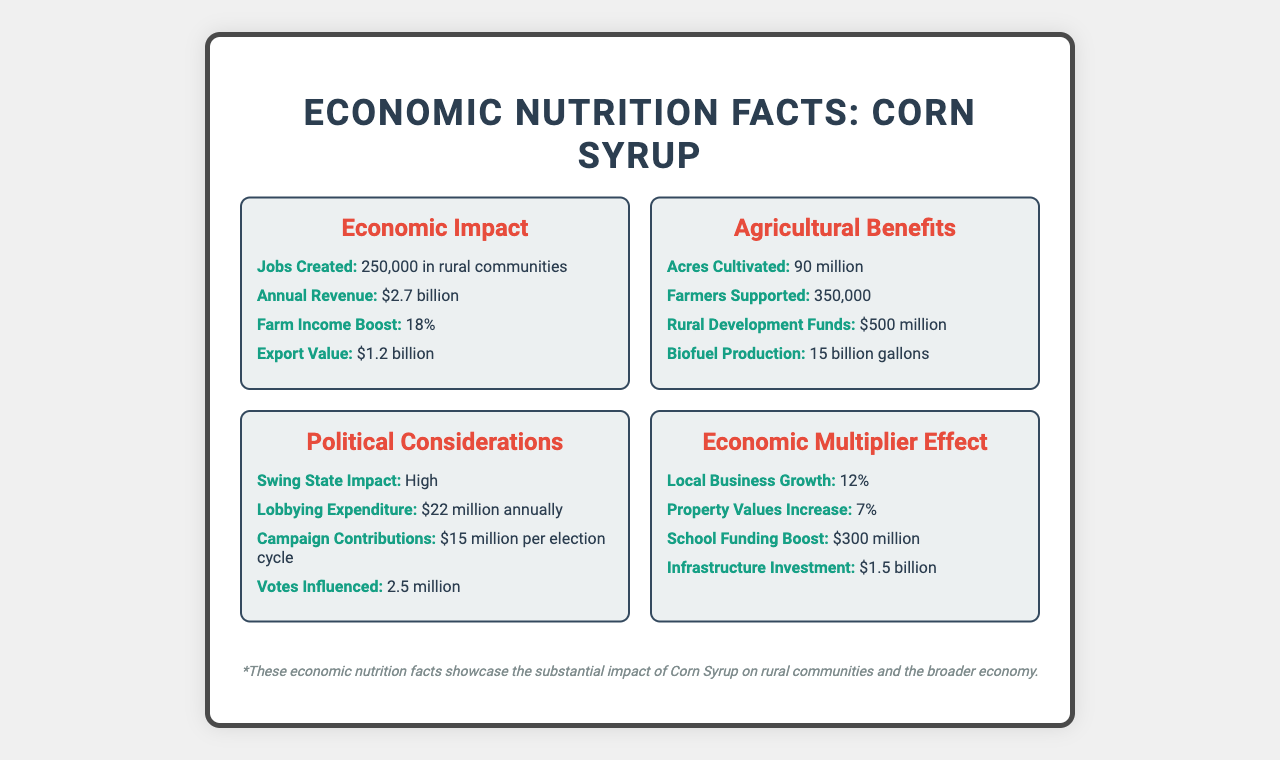What is the annual revenue generated by the Corn Syrup product? The document states that the annual revenue from the Corn Syrup product is $2.7 billion.
Answer: $2.7 billion How many jobs were created in rural communities due to the Corn Syrup product? According to the Economic Impact section, the Corn Syrup product generated 250,000 jobs in rural communities.
Answer: 250,000 What percentage increase did farm income experience? The Economic Impact section mentions an 18% boost in farm income due to the Corn Syrup product.
Answer: 18% How much biofuel is produced annually from the Corn Syrup product? The Agricultural Benefits section lists that 15 billion gallons of biofuel are produced annually from the Corn Syrup product.
Answer: 15 billion gallons Which factor had the highest financial contribution to rural development? A. Jobs Created B. Rural Development Funds C. Disaster Relief Funds D. Research Grants Rural Development Funds amount to $500 million, which is higher than Research Grants and Disaster Relief Funds.
Answer: B How much is spent on lobbying for the Corn Syrup industry annually? The Political Considerations section states that $22 million is spent annually on lobbying.
Answer: $22 million What is the market dominance of the US in the global market for Corn Syrup? According to the Global Market Share section, the US has a 45% market dominance in the global market.
Answer: 45% What is the impact of Corn Syrup on swing states? A. Low B. Medium C. High D. None The Political Considerations section mentions that the impact on swing states is high.
Answer: C Does the Corn Syrup product contribute significantly to food security? The Consumer Impact section highlights a significant contribution to food security.
Answer: Yes Summarize the main idea of the document. The Corn Syrup product generates significant revenue, supports numerous jobs, enhances farm income, and contributes to biofuel production and rural development. It also influences political factors, benefits local economies, and contributes to food security.
Answer: The document highlights the economic and agricultural benefits of the subsidized Corn Syrup product, including its impact on rural communities, market share, political considerations, and consumer impact. What is the reduction in the average price of Corn Syrup due to subsidies? The Consumer Impact section notes a 15% average price reduction due to subsidies.
Answer: 15% How much funding boost did local schools receive due to the Corn Syrup economic impact? The Economic Multiplier Effect section indicates a $300 million funding boost for local schools.
Answer: $300 million Which of the following funds is not mentioned directly in the document? A. Export Value B. Biofuel Production C. Health Research Grants D. Votes Influenced The document does not mention health research grants, while the other options are specified in various sections.
Answer: C What is the total value of federal subsidies for the Corn Syrup industry? The Subsidies and Support section states that federal subsidies amounted to $5.5 billion.
Answer: $5.5 billion How many acres are cultivated for Corn Syrup production? The Agricultural Benefits section lists that 90 million acres are cultivated for producing Corn Syrup.
Answer: 90 million What impact does the Corn Syrup product have on local business growth? The Economic Multiplier Effect section states that local business growth increased by 12% due to the Corn Syrup product.
Answer: 12% How significant is the export value of Corn Syrup? A. Minor B. Moderate C. Significant D. Insignificant The Economic Impact section mentions an export value of $1.2 billion, indicating a significant impact.
Answer: C What percentage of the global market does a foreign competitor control? The document only specifies the US market dominance at 45%, but does not provide information about the percentage controlled by foreign competitors.
Answer: Cannot be determined How much is invested in infrastructure as a result of the economic impact of Corn Syrup? The Economic Multiplier Effect section mentions a $1.5 billion investment in infrastructure.
Answer: $1.5 billion 